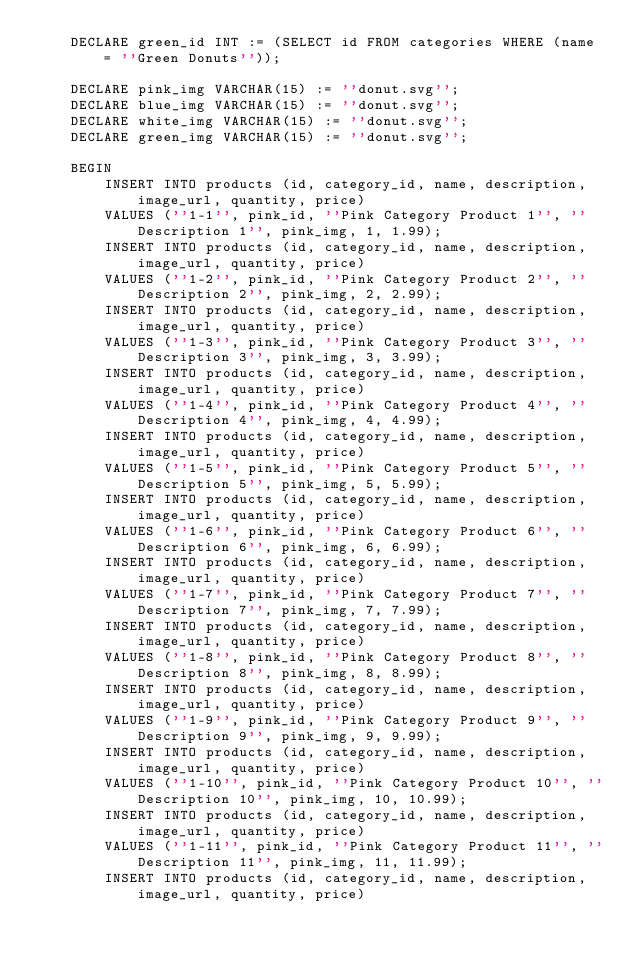Convert code to text. <code><loc_0><loc_0><loc_500><loc_500><_SQL_>    DECLARE green_id INT := (SELECT id FROM categories WHERE (name = ''Green Donuts''));

    DECLARE pink_img VARCHAR(15) := ''donut.svg'';
    DECLARE blue_img VARCHAR(15) := ''donut.svg'';
    DECLARE white_img VARCHAR(15) := ''donut.svg'';
    DECLARE green_img VARCHAR(15) := ''donut.svg'';

    BEGIN
        INSERT INTO products (id, category_id, name, description, image_url, quantity, price)
        VALUES (''1-1'', pink_id, ''Pink Category Product 1'', ''Description 1'', pink_img, 1, 1.99);
        INSERT INTO products (id, category_id, name, description, image_url, quantity, price)
        VALUES (''1-2'', pink_id, ''Pink Category Product 2'', ''Description 2'', pink_img, 2, 2.99);
        INSERT INTO products (id, category_id, name, description, image_url, quantity, price)
        VALUES (''1-3'', pink_id, ''Pink Category Product 3'', ''Description 3'', pink_img, 3, 3.99);
        INSERT INTO products (id, category_id, name, description, image_url, quantity, price)
        VALUES (''1-4'', pink_id, ''Pink Category Product 4'', ''Description 4'', pink_img, 4, 4.99);
        INSERT INTO products (id, category_id, name, description, image_url, quantity, price)
        VALUES (''1-5'', pink_id, ''Pink Category Product 5'', ''Description 5'', pink_img, 5, 5.99);
        INSERT INTO products (id, category_id, name, description, image_url, quantity, price)
        VALUES (''1-6'', pink_id, ''Pink Category Product 6'', ''Description 6'', pink_img, 6, 6.99);
        INSERT INTO products (id, category_id, name, description, image_url, quantity, price)
        VALUES (''1-7'', pink_id, ''Pink Category Product 7'', ''Description 7'', pink_img, 7, 7.99);
        INSERT INTO products (id, category_id, name, description, image_url, quantity, price)
        VALUES (''1-8'', pink_id, ''Pink Category Product 8'', ''Description 8'', pink_img, 8, 8.99);
        INSERT INTO products (id, category_id, name, description, image_url, quantity, price)
        VALUES (''1-9'', pink_id, ''Pink Category Product 9'', ''Description 9'', pink_img, 9, 9.99);
        INSERT INTO products (id, category_id, name, description, image_url, quantity, price)
        VALUES (''1-10'', pink_id, ''Pink Category Product 10'', ''Description 10'', pink_img, 10, 10.99);
        INSERT INTO products (id, category_id, name, description, image_url, quantity, price)
        VALUES (''1-11'', pink_id, ''Pink Category Product 11'', ''Description 11'', pink_img, 11, 11.99);
        INSERT INTO products (id, category_id, name, description, image_url, quantity, price)</code> 